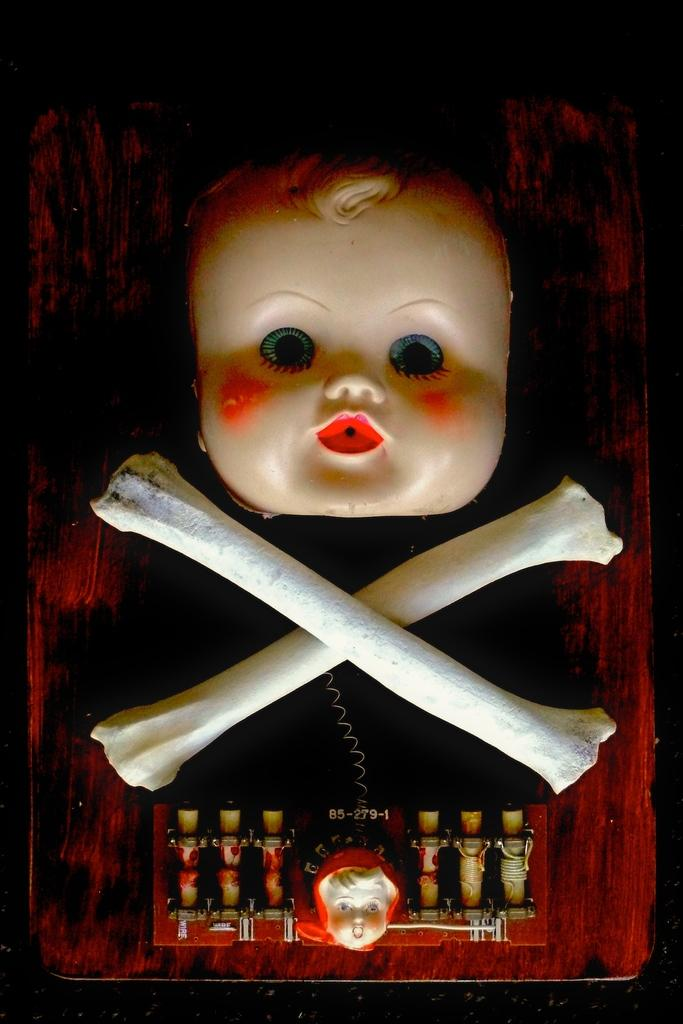What type of toy is present in the image? There is a toy head in the image. What other objects can be seen in the image? Skeleton bones are present in the image. Where are the toy head and skeleton bones located? Both the toy head and skeleton bones are on a table. What type of police equipment can be seen in the image? There is no police equipment present in the image. Can you tell me the color of the kitten in the image? There is no kitten present in the image. 